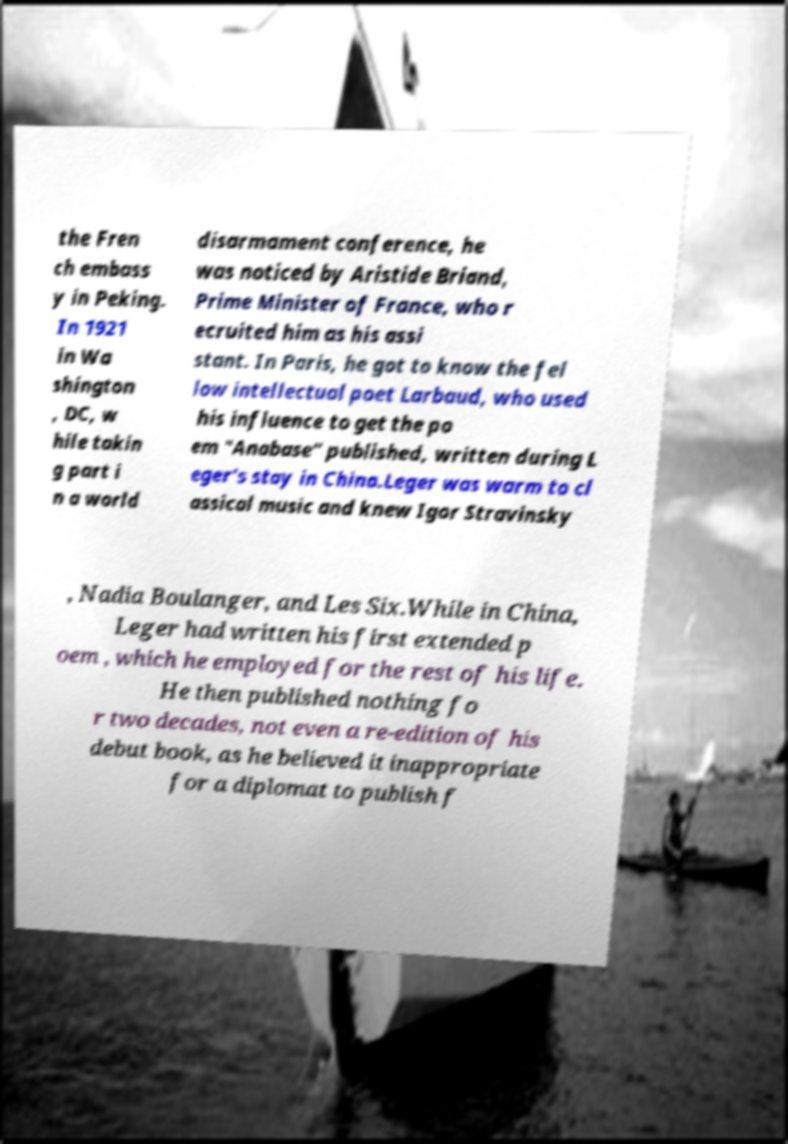There's text embedded in this image that I need extracted. Can you transcribe it verbatim? the Fren ch embass y in Peking. In 1921 in Wa shington , DC, w hile takin g part i n a world disarmament conference, he was noticed by Aristide Briand, Prime Minister of France, who r ecruited him as his assi stant. In Paris, he got to know the fel low intellectual poet Larbaud, who used his influence to get the po em "Anabase" published, written during L eger's stay in China.Leger was warm to cl assical music and knew Igor Stravinsky , Nadia Boulanger, and Les Six.While in China, Leger had written his first extended p oem , which he employed for the rest of his life. He then published nothing fo r two decades, not even a re-edition of his debut book, as he believed it inappropriate for a diplomat to publish f 